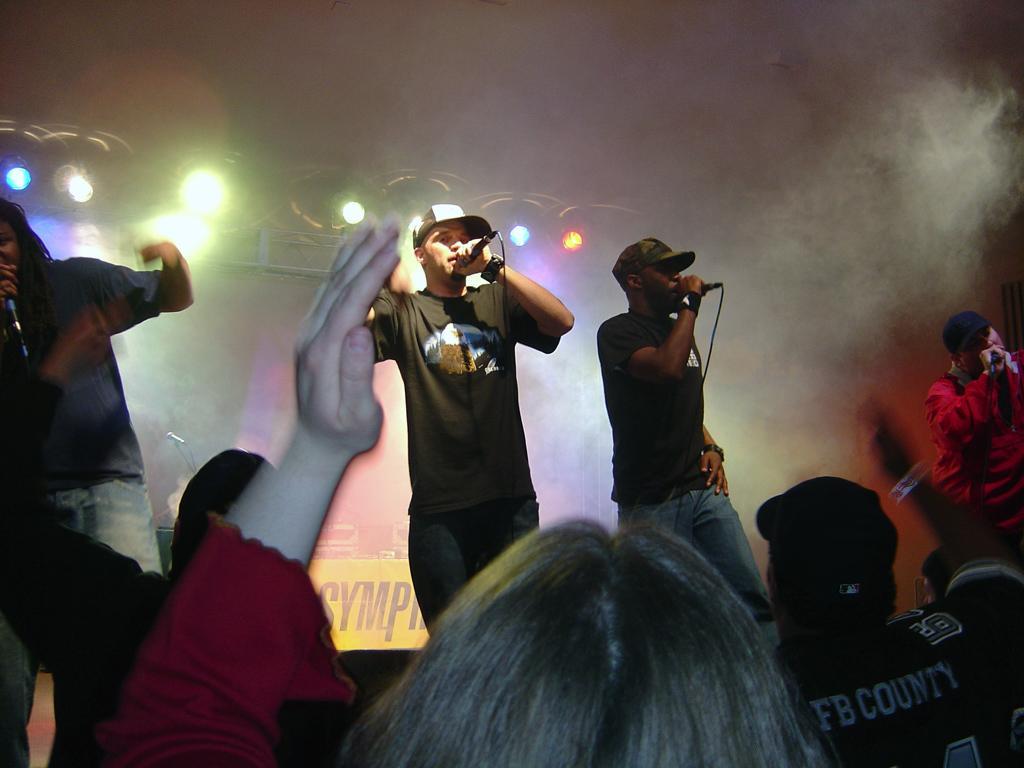Can you describe this image briefly? In the picture we can see two men are standing on the stage and singing a song and are in T-shirts and caps and in front of them, we can see some people are raising their hands and encouraging them and in the background we can see focus lights and smoke. 